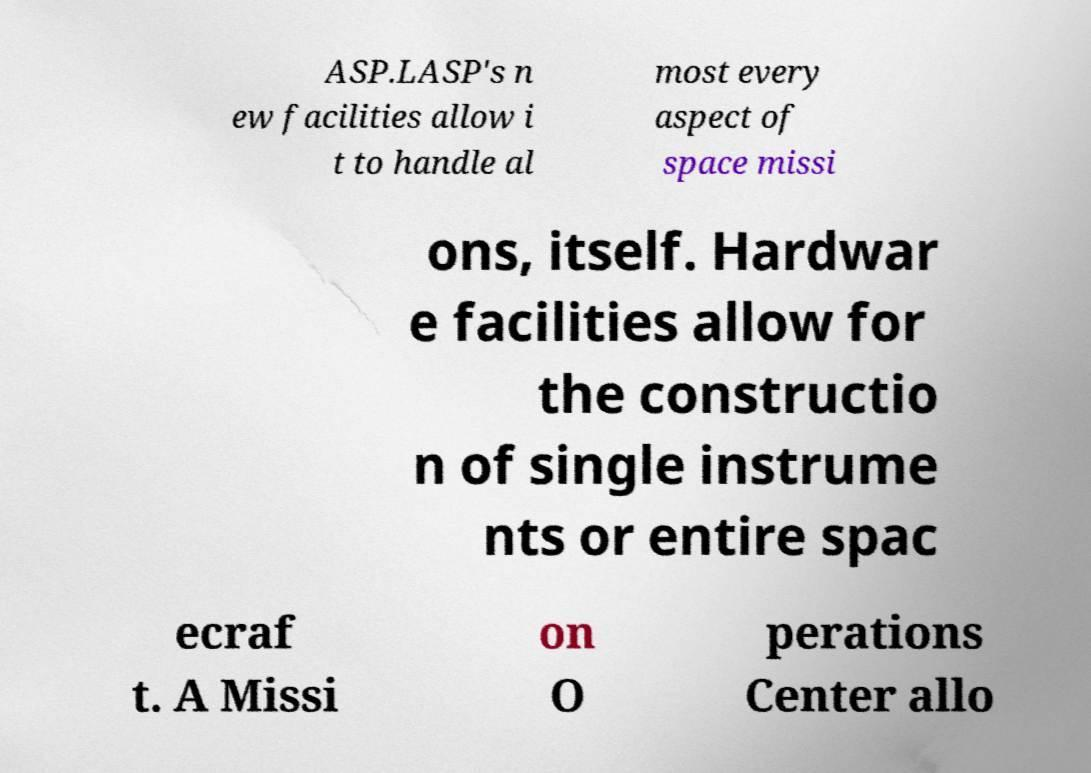Please read and relay the text visible in this image. What does it say? ASP.LASP's n ew facilities allow i t to handle al most every aspect of space missi ons, itself. Hardwar e facilities allow for the constructio n of single instrume nts or entire spac ecraf t. A Missi on O perations Center allo 